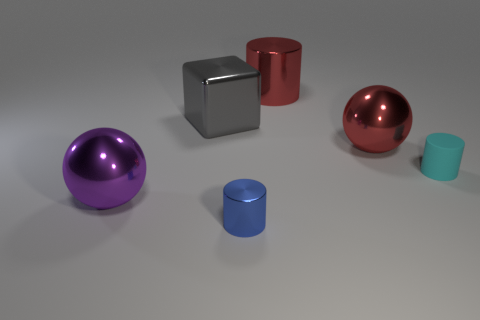Add 4 big purple shiny balls. How many objects exist? 10 Subtract all balls. How many objects are left? 4 Add 5 gray metal cubes. How many gray metal cubes exist? 6 Subtract 0 green cylinders. How many objects are left? 6 Subtract all big red metallic cylinders. Subtract all matte cylinders. How many objects are left? 4 Add 5 small cyan things. How many small cyan things are left? 6 